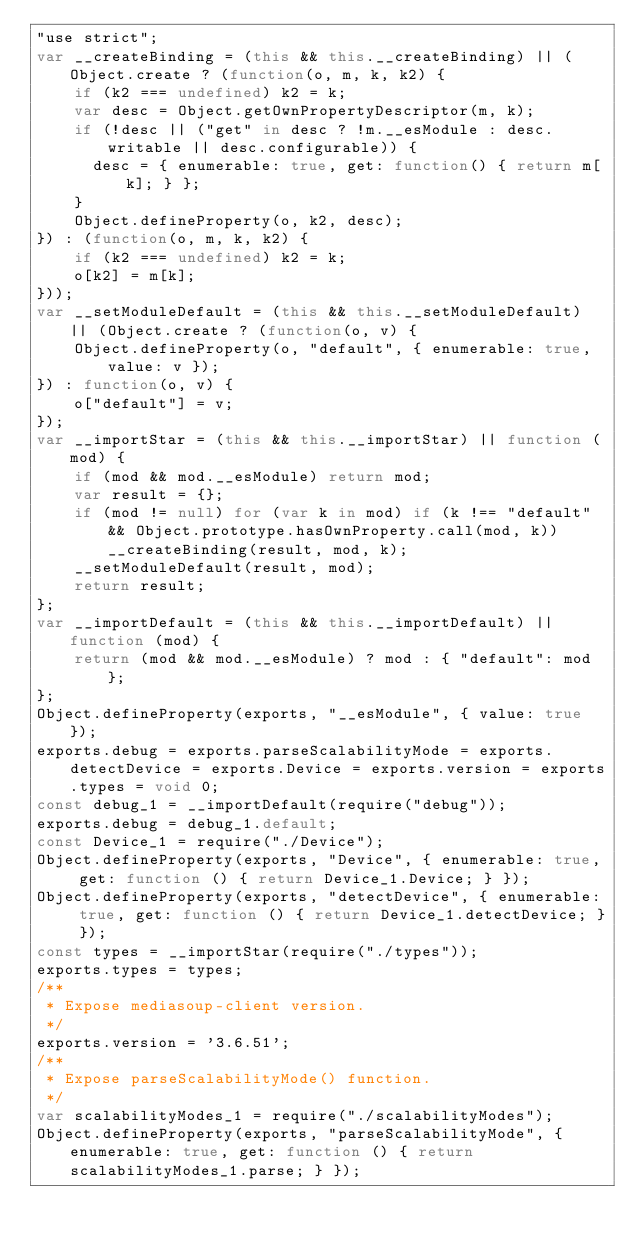<code> <loc_0><loc_0><loc_500><loc_500><_JavaScript_>"use strict";
var __createBinding = (this && this.__createBinding) || (Object.create ? (function(o, m, k, k2) {
    if (k2 === undefined) k2 = k;
    var desc = Object.getOwnPropertyDescriptor(m, k);
    if (!desc || ("get" in desc ? !m.__esModule : desc.writable || desc.configurable)) {
      desc = { enumerable: true, get: function() { return m[k]; } };
    }
    Object.defineProperty(o, k2, desc);
}) : (function(o, m, k, k2) {
    if (k2 === undefined) k2 = k;
    o[k2] = m[k];
}));
var __setModuleDefault = (this && this.__setModuleDefault) || (Object.create ? (function(o, v) {
    Object.defineProperty(o, "default", { enumerable: true, value: v });
}) : function(o, v) {
    o["default"] = v;
});
var __importStar = (this && this.__importStar) || function (mod) {
    if (mod && mod.__esModule) return mod;
    var result = {};
    if (mod != null) for (var k in mod) if (k !== "default" && Object.prototype.hasOwnProperty.call(mod, k)) __createBinding(result, mod, k);
    __setModuleDefault(result, mod);
    return result;
};
var __importDefault = (this && this.__importDefault) || function (mod) {
    return (mod && mod.__esModule) ? mod : { "default": mod };
};
Object.defineProperty(exports, "__esModule", { value: true });
exports.debug = exports.parseScalabilityMode = exports.detectDevice = exports.Device = exports.version = exports.types = void 0;
const debug_1 = __importDefault(require("debug"));
exports.debug = debug_1.default;
const Device_1 = require("./Device");
Object.defineProperty(exports, "Device", { enumerable: true, get: function () { return Device_1.Device; } });
Object.defineProperty(exports, "detectDevice", { enumerable: true, get: function () { return Device_1.detectDevice; } });
const types = __importStar(require("./types"));
exports.types = types;
/**
 * Expose mediasoup-client version.
 */
exports.version = '3.6.51';
/**
 * Expose parseScalabilityMode() function.
 */
var scalabilityModes_1 = require("./scalabilityModes");
Object.defineProperty(exports, "parseScalabilityMode", { enumerable: true, get: function () { return scalabilityModes_1.parse; } });
</code> 